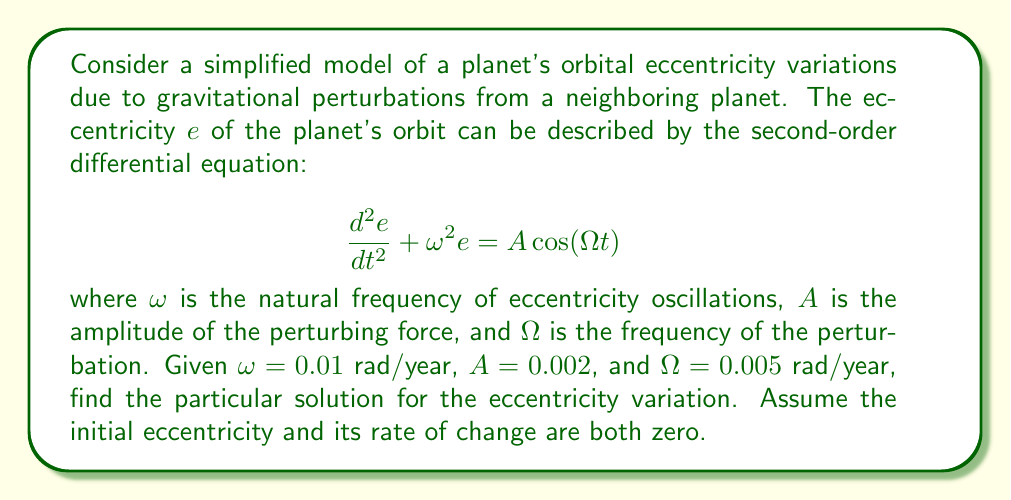Provide a solution to this math problem. To solve this problem, we'll follow these steps:

1) The general form of the particular solution for a forced oscillation with cosine forcing is:

   $$e_p(t) = C\cos(\Omega t)$$

   where $C$ is a constant we need to determine.

2) Substitute this into the original differential equation:

   $$-C\Omega^2\cos(\Omega t) + \omega^2C\cos(\Omega t) = A\cos(\Omega t)$$

3) Equate coefficients:

   $$C(\omega^2 - \Omega^2) = A$$

4) Solve for $C$:

   $$C = \frac{A}{\omega^2 - \Omega^2}$$

5) Substitute the given values:

   $$C = \frac{0.002}{(0.01)^2 - (0.005)^2} = \frac{0.002}{0.0001 - 0.000025} = \frac{0.002}{0.000075} = 26.67$$

6) Therefore, the particular solution is:

   $$e_p(t) = 26.67\cos(0.005t)$$

This solution represents the steady-state response of the system to the perturbing force, ignoring any transient effects.
Answer: $$e_p(t) = 26.67\cos(0.005t)$$ 